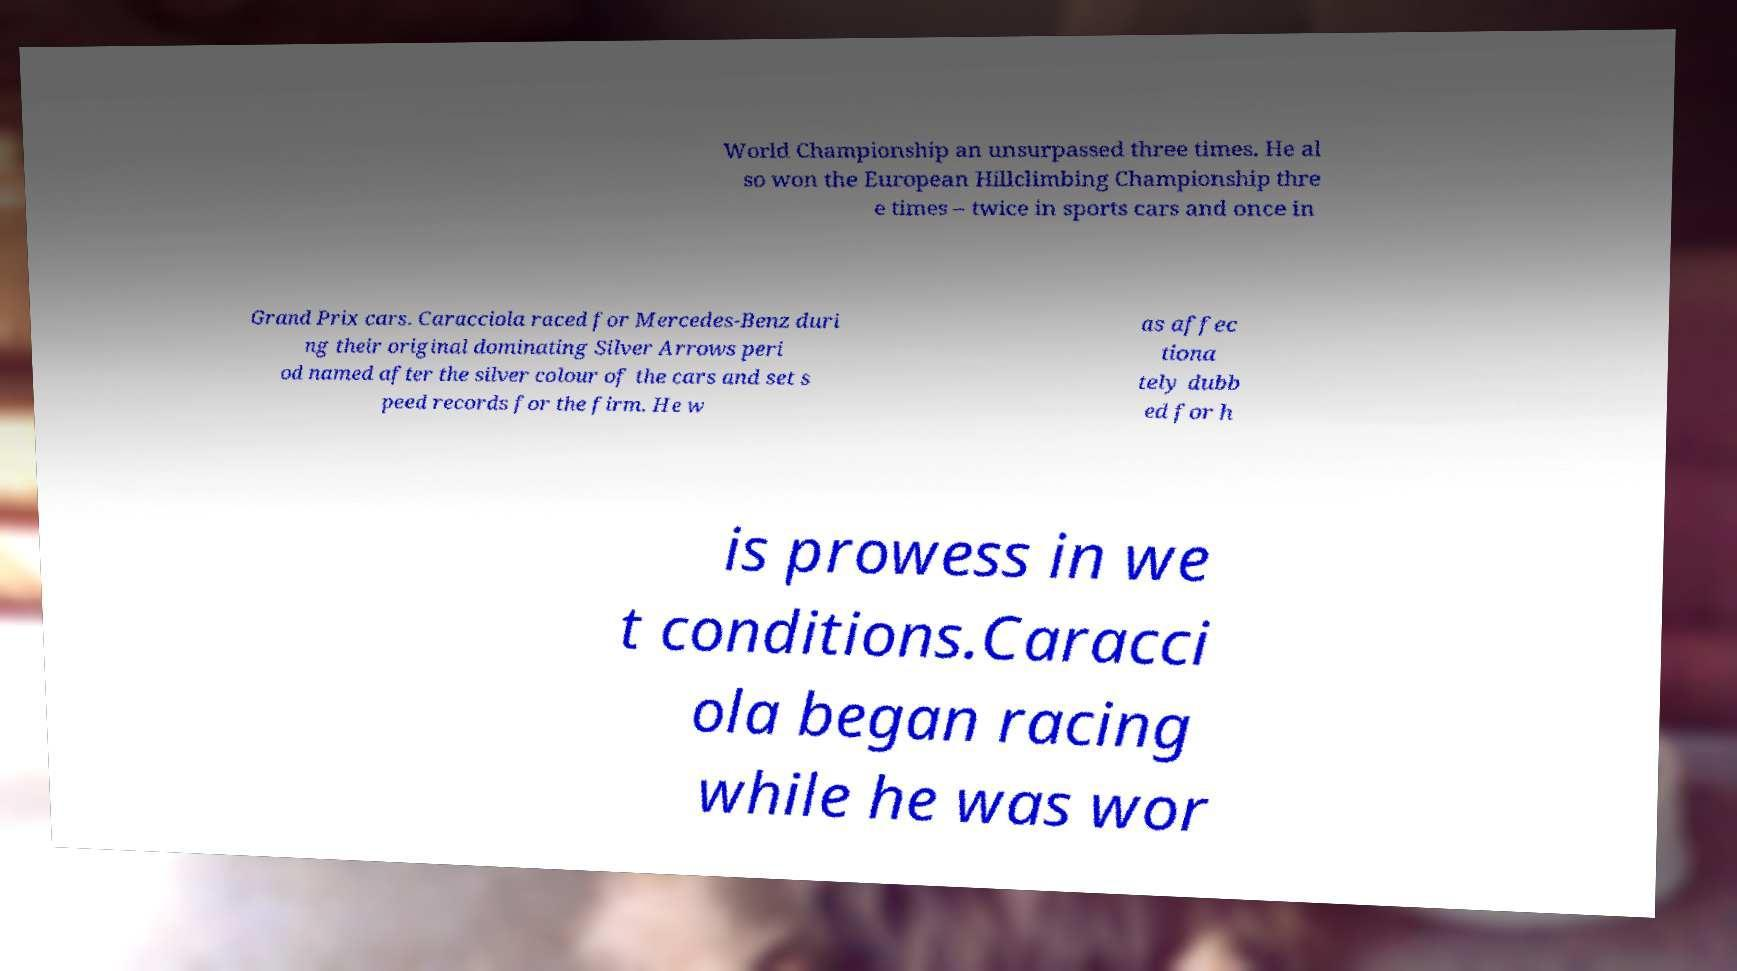Can you accurately transcribe the text from the provided image for me? World Championship an unsurpassed three times. He al so won the European Hillclimbing Championship thre e times – twice in sports cars and once in Grand Prix cars. Caracciola raced for Mercedes-Benz duri ng their original dominating Silver Arrows peri od named after the silver colour of the cars and set s peed records for the firm. He w as affec tiona tely dubb ed for h is prowess in we t conditions.Caracci ola began racing while he was wor 